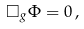Convert formula to latex. <formula><loc_0><loc_0><loc_500><loc_500>\Box _ { g } \Phi = 0 \, ,</formula> 